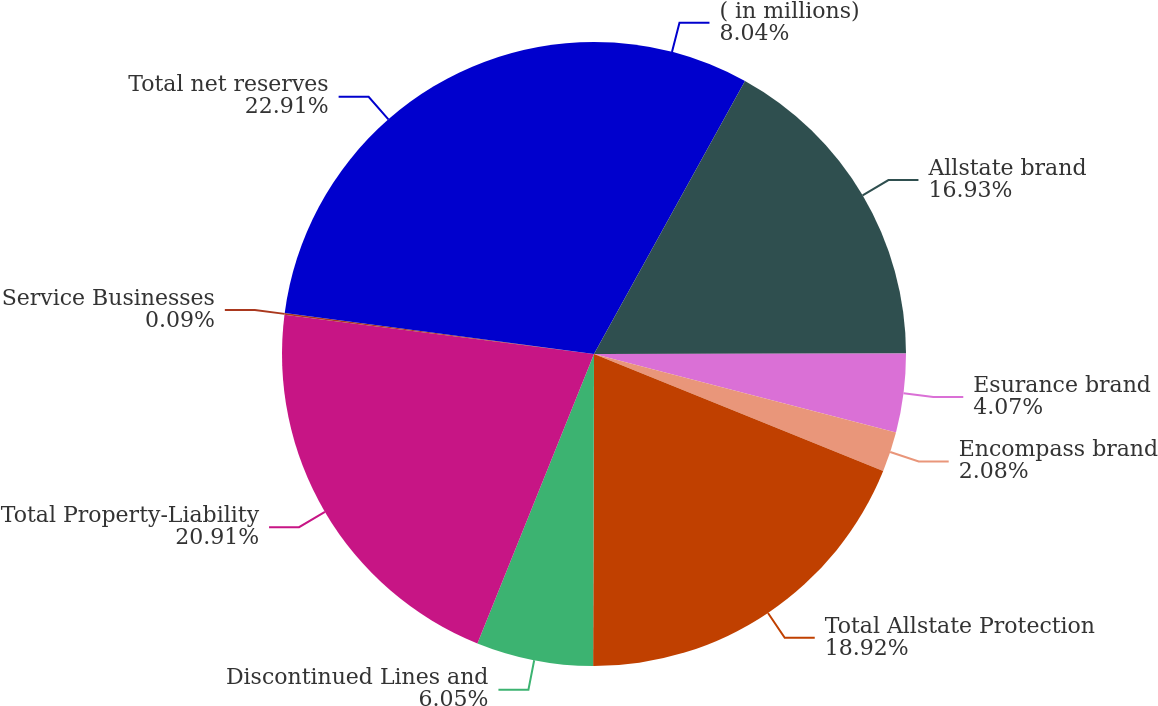Convert chart. <chart><loc_0><loc_0><loc_500><loc_500><pie_chart><fcel>( in millions)<fcel>Allstate brand<fcel>Esurance brand<fcel>Encompass brand<fcel>Total Allstate Protection<fcel>Discontinued Lines and<fcel>Total Property-Liability<fcel>Service Businesses<fcel>Total net reserves<nl><fcel>8.04%<fcel>16.93%<fcel>4.07%<fcel>2.08%<fcel>18.92%<fcel>6.05%<fcel>20.91%<fcel>0.09%<fcel>22.9%<nl></chart> 